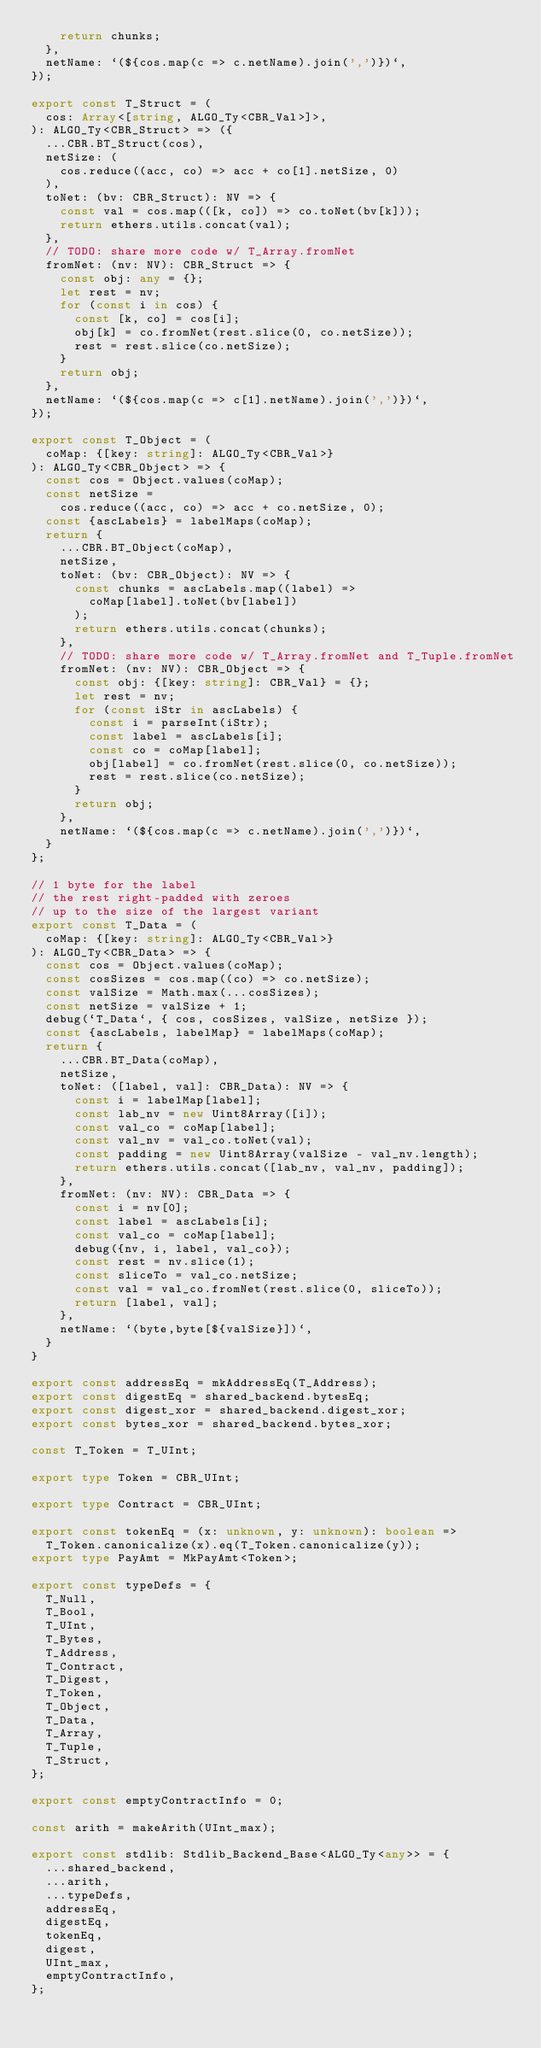<code> <loc_0><loc_0><loc_500><loc_500><_TypeScript_>    return chunks;
  },
  netName: `(${cos.map(c => c.netName).join(',')})`,
});

export const T_Struct = (
  cos: Array<[string, ALGO_Ty<CBR_Val>]>,
): ALGO_Ty<CBR_Struct> => ({
  ...CBR.BT_Struct(cos),
  netSize: (
    cos.reduce((acc, co) => acc + co[1].netSize, 0)
  ),
  toNet: (bv: CBR_Struct): NV => {
    const val = cos.map(([k, co]) => co.toNet(bv[k]));
    return ethers.utils.concat(val);
  },
  // TODO: share more code w/ T_Array.fromNet
  fromNet: (nv: NV): CBR_Struct => {
    const obj: any = {};
    let rest = nv;
    for (const i in cos) {
      const [k, co] = cos[i];
      obj[k] = co.fromNet(rest.slice(0, co.netSize));
      rest = rest.slice(co.netSize);
    }
    return obj;
  },
  netName: `(${cos.map(c => c[1].netName).join(',')})`,
});

export const T_Object = (
  coMap: {[key: string]: ALGO_Ty<CBR_Val>}
): ALGO_Ty<CBR_Object> => {
  const cos = Object.values(coMap);
  const netSize =
    cos.reduce((acc, co) => acc + co.netSize, 0);
  const {ascLabels} = labelMaps(coMap);
  return {
    ...CBR.BT_Object(coMap),
    netSize,
    toNet: (bv: CBR_Object): NV => {
      const chunks = ascLabels.map((label) =>
        coMap[label].toNet(bv[label])
      );
      return ethers.utils.concat(chunks);
    },
    // TODO: share more code w/ T_Array.fromNet and T_Tuple.fromNet
    fromNet: (nv: NV): CBR_Object => {
      const obj: {[key: string]: CBR_Val} = {};
      let rest = nv;
      for (const iStr in ascLabels) {
        const i = parseInt(iStr);
        const label = ascLabels[i];
        const co = coMap[label];
        obj[label] = co.fromNet(rest.slice(0, co.netSize));
        rest = rest.slice(co.netSize);
      }
      return obj;
    },
    netName: `(${cos.map(c => c.netName).join(',')})`,
  }
};

// 1 byte for the label
// the rest right-padded with zeroes
// up to the size of the largest variant
export const T_Data = (
  coMap: {[key: string]: ALGO_Ty<CBR_Val>}
): ALGO_Ty<CBR_Data> => {
  const cos = Object.values(coMap);
  const cosSizes = cos.map((co) => co.netSize);
  const valSize = Math.max(...cosSizes);
  const netSize = valSize + 1;
  debug(`T_Data`, { cos, cosSizes, valSize, netSize });
  const {ascLabels, labelMap} = labelMaps(coMap);
  return {
    ...CBR.BT_Data(coMap),
    netSize,
    toNet: ([label, val]: CBR_Data): NV => {
      const i = labelMap[label];
      const lab_nv = new Uint8Array([i]);
      const val_co = coMap[label];
      const val_nv = val_co.toNet(val);
      const padding = new Uint8Array(valSize - val_nv.length);
      return ethers.utils.concat([lab_nv, val_nv, padding]);
    },
    fromNet: (nv: NV): CBR_Data => {
      const i = nv[0];
      const label = ascLabels[i];
      const val_co = coMap[label];
      debug({nv, i, label, val_co});
      const rest = nv.slice(1);
      const sliceTo = val_co.netSize;
      const val = val_co.fromNet(rest.slice(0, sliceTo));
      return [label, val];
    },
    netName: `(byte,byte[${valSize}])`,
  }
}

export const addressEq = mkAddressEq(T_Address);
export const digestEq = shared_backend.bytesEq;
export const digest_xor = shared_backend.digest_xor;
export const bytes_xor = shared_backend.bytes_xor;

const T_Token = T_UInt;

export type Token = CBR_UInt;

export type Contract = CBR_UInt;

export const tokenEq = (x: unknown, y: unknown): boolean =>
  T_Token.canonicalize(x).eq(T_Token.canonicalize(y));
export type PayAmt = MkPayAmt<Token>;

export const typeDefs = {
  T_Null,
  T_Bool,
  T_UInt,
  T_Bytes,
  T_Address,
  T_Contract,
  T_Digest,
  T_Token,
  T_Object,
  T_Data,
  T_Array,
  T_Tuple,
  T_Struct,
};

export const emptyContractInfo = 0;

const arith = makeArith(UInt_max);

export const stdlib: Stdlib_Backend_Base<ALGO_Ty<any>> = {
  ...shared_backend,
  ...arith,
  ...typeDefs,
  addressEq,
  digestEq,
  tokenEq,
  digest,
  UInt_max,
  emptyContractInfo,
};
</code> 